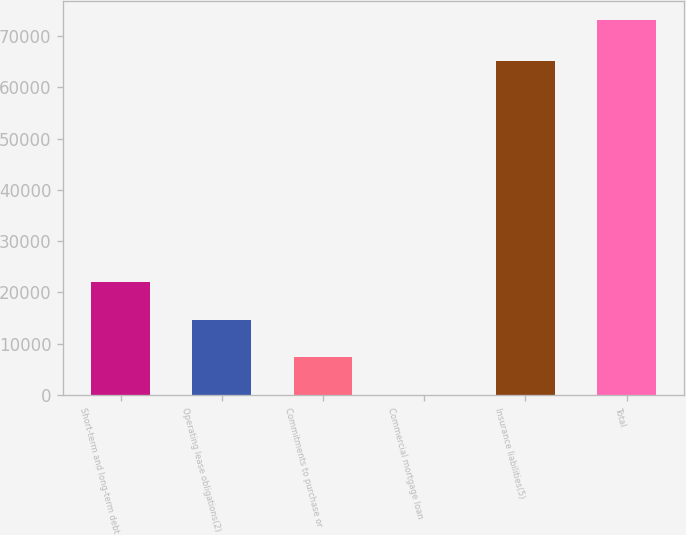Convert chart to OTSL. <chart><loc_0><loc_0><loc_500><loc_500><bar_chart><fcel>Short-term and long-term debt<fcel>Operating lease obligations(2)<fcel>Commitments to purchase or<fcel>Commercial mortgage loan<fcel>Insurance liabilities(5)<fcel>Total<nl><fcel>21989.3<fcel>14674.2<fcel>7359.1<fcel>44<fcel>65192<fcel>73195<nl></chart> 